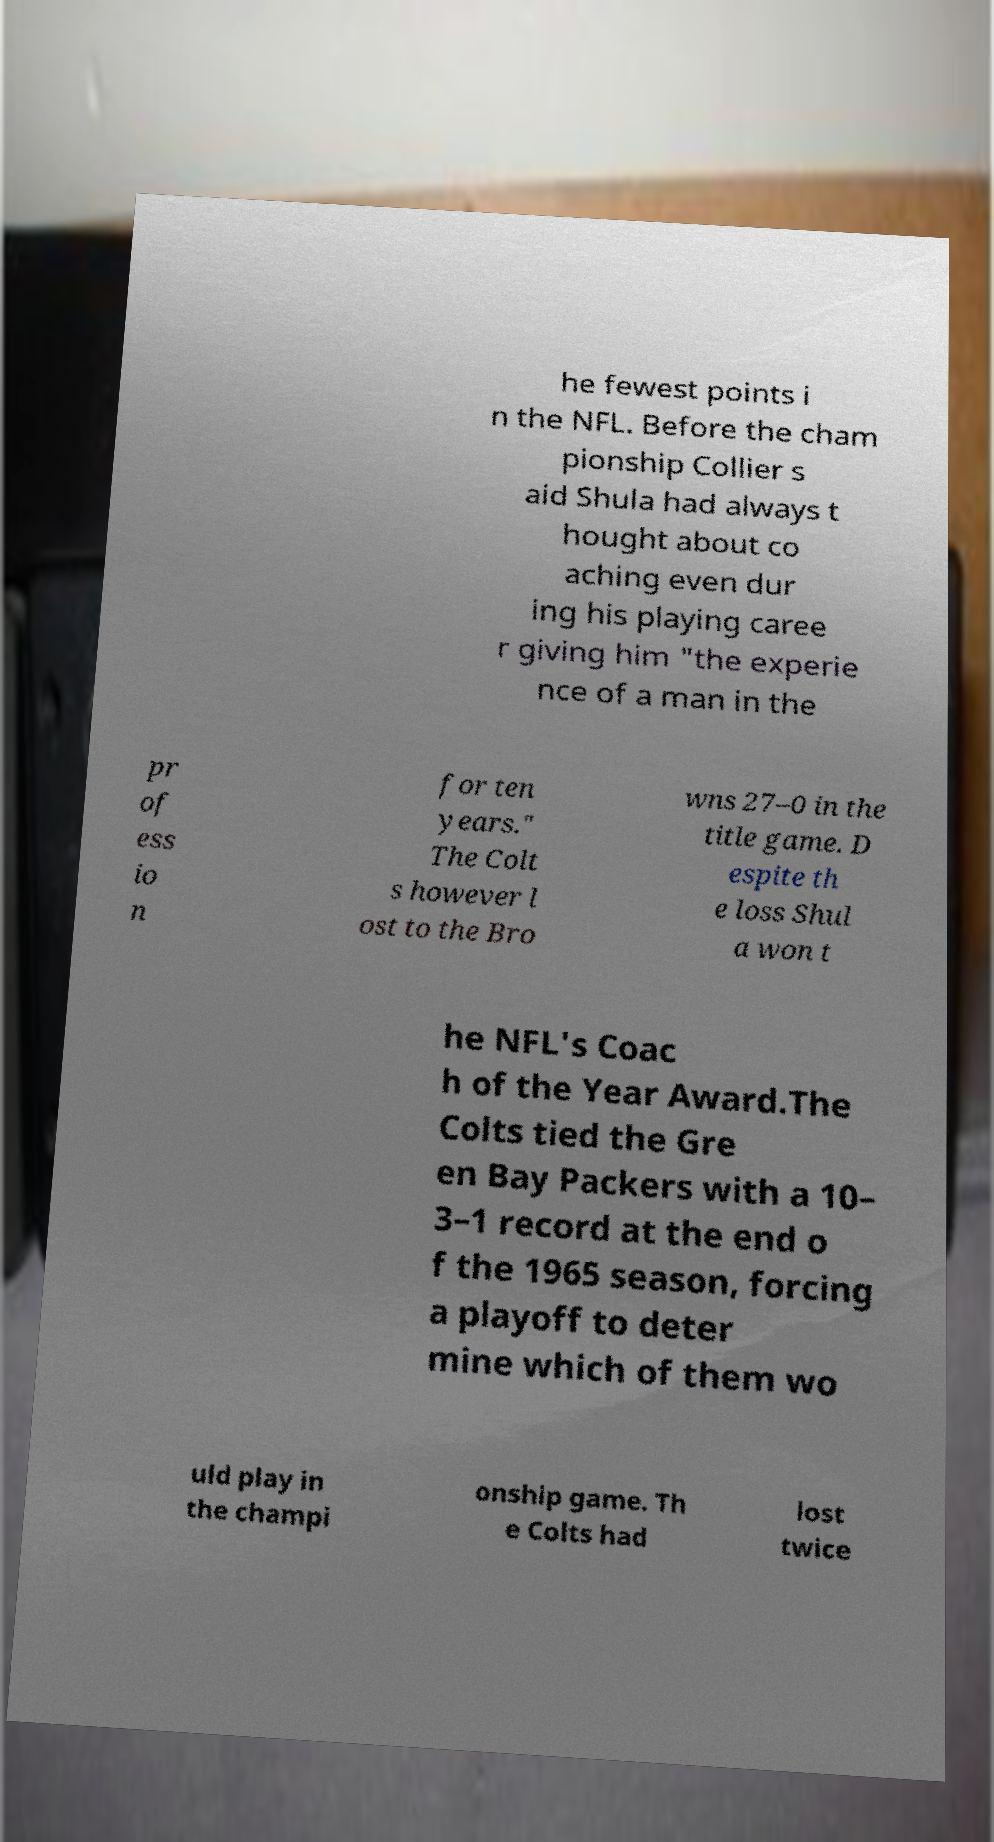I need the written content from this picture converted into text. Can you do that? he fewest points i n the NFL. Before the cham pionship Collier s aid Shula had always t hought about co aching even dur ing his playing caree r giving him "the experie nce of a man in the pr of ess io n for ten years." The Colt s however l ost to the Bro wns 27–0 in the title game. D espite th e loss Shul a won t he NFL's Coac h of the Year Award.The Colts tied the Gre en Bay Packers with a 10– 3–1 record at the end o f the 1965 season, forcing a playoff to deter mine which of them wo uld play in the champi onship game. Th e Colts had lost twice 